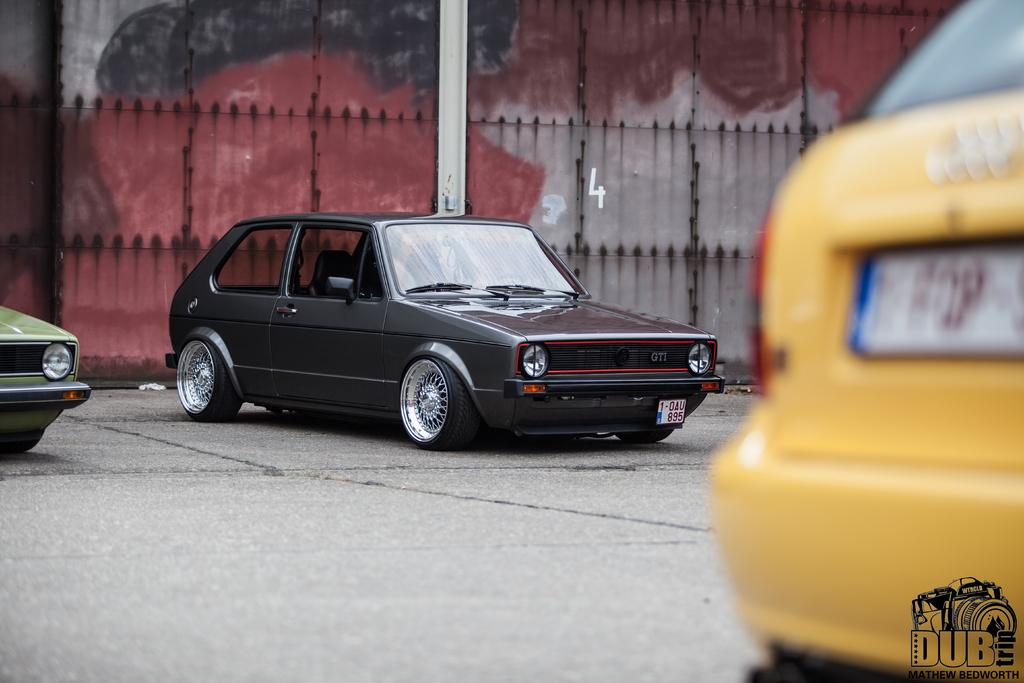<image>
Provide a brief description of the given image. Dub trip is on the back bumper of a yellow vehicle. 